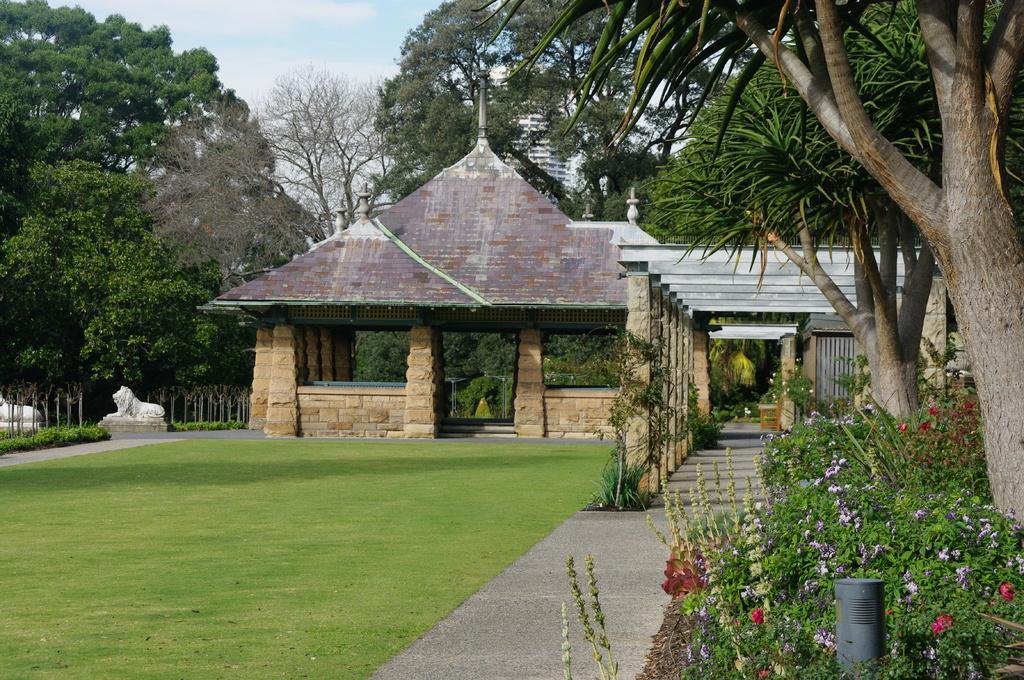In one or two sentences, can you explain what this image depicts? In the right bottom of the picture, we see the plants which have flowers and these flowers are in white and red color. In between the plants, we see a pole. There are trees on the right side. At the bottom of the picture, we see the road and the grass. In the middle of the picture, we see a cottage like. Beside that, there are pillars. On the left side, we see the statue of the lion. There are trees in the background. At the top, we see the sky. 